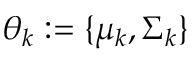Convert formula to latex. <formula><loc_0><loc_0><loc_500><loc_500>\theta _ { k } \colon = \{ \mu _ { k } , \Sigma _ { k } \}</formula> 